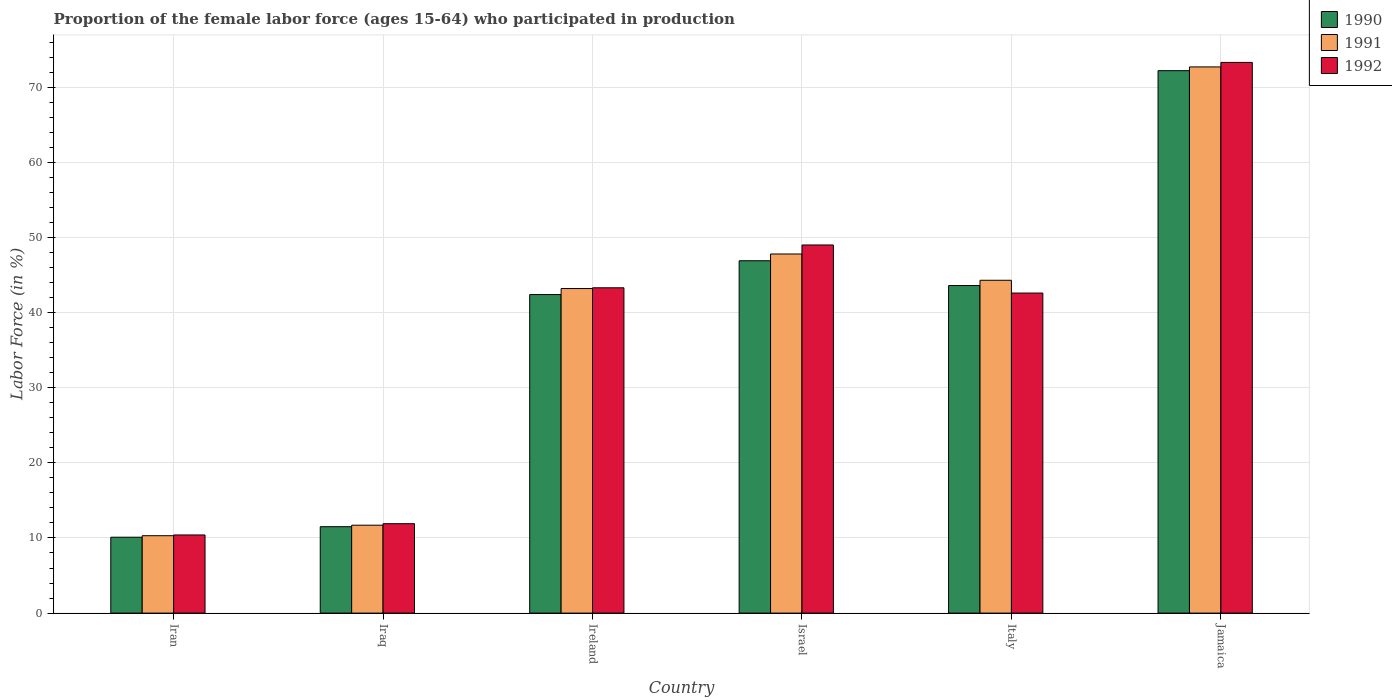Are the number of bars per tick equal to the number of legend labels?
Your answer should be very brief. Yes. How many bars are there on the 2nd tick from the left?
Offer a very short reply. 3. How many bars are there on the 3rd tick from the right?
Provide a succinct answer. 3. What is the label of the 2nd group of bars from the left?
Give a very brief answer. Iraq. In how many cases, is the number of bars for a given country not equal to the number of legend labels?
Provide a succinct answer. 0. What is the proportion of the female labor force who participated in production in 1991 in Israel?
Provide a succinct answer. 47.8. Across all countries, what is the maximum proportion of the female labor force who participated in production in 1992?
Your response must be concise. 73.3. Across all countries, what is the minimum proportion of the female labor force who participated in production in 1992?
Offer a terse response. 10.4. In which country was the proportion of the female labor force who participated in production in 1992 maximum?
Your answer should be compact. Jamaica. In which country was the proportion of the female labor force who participated in production in 1991 minimum?
Your answer should be very brief. Iran. What is the total proportion of the female labor force who participated in production in 1992 in the graph?
Keep it short and to the point. 230.5. What is the difference between the proportion of the female labor force who participated in production in 1992 in Iraq and that in Italy?
Provide a short and direct response. -30.7. What is the difference between the proportion of the female labor force who participated in production in 1992 in Iran and the proportion of the female labor force who participated in production in 1991 in Iraq?
Offer a very short reply. -1.3. What is the average proportion of the female labor force who participated in production in 1992 per country?
Give a very brief answer. 38.42. What is the difference between the proportion of the female labor force who participated in production of/in 1991 and proportion of the female labor force who participated in production of/in 1990 in Iraq?
Offer a very short reply. 0.2. In how many countries, is the proportion of the female labor force who participated in production in 1991 greater than 24 %?
Make the answer very short. 4. What is the ratio of the proportion of the female labor force who participated in production in 1991 in Ireland to that in Jamaica?
Provide a short and direct response. 0.59. Is the difference between the proportion of the female labor force who participated in production in 1991 in Israel and Italy greater than the difference between the proportion of the female labor force who participated in production in 1990 in Israel and Italy?
Give a very brief answer. Yes. What is the difference between the highest and the second highest proportion of the female labor force who participated in production in 1992?
Your answer should be very brief. 30. What is the difference between the highest and the lowest proportion of the female labor force who participated in production in 1990?
Make the answer very short. 62.1. In how many countries, is the proportion of the female labor force who participated in production in 1990 greater than the average proportion of the female labor force who participated in production in 1990 taken over all countries?
Ensure brevity in your answer.  4. Is the sum of the proportion of the female labor force who participated in production in 1992 in Ireland and Italy greater than the maximum proportion of the female labor force who participated in production in 1990 across all countries?
Offer a terse response. Yes. What does the 3rd bar from the left in Jamaica represents?
Offer a very short reply. 1992. Is it the case that in every country, the sum of the proportion of the female labor force who participated in production in 1992 and proportion of the female labor force who participated in production in 1991 is greater than the proportion of the female labor force who participated in production in 1990?
Provide a succinct answer. Yes. How many bars are there?
Your response must be concise. 18. How many countries are there in the graph?
Offer a very short reply. 6. What is the difference between two consecutive major ticks on the Y-axis?
Offer a very short reply. 10. Does the graph contain grids?
Provide a short and direct response. Yes. Where does the legend appear in the graph?
Provide a succinct answer. Top right. What is the title of the graph?
Offer a very short reply. Proportion of the female labor force (ages 15-64) who participated in production. Does "2008" appear as one of the legend labels in the graph?
Ensure brevity in your answer.  No. What is the label or title of the Y-axis?
Offer a terse response. Labor Force (in %). What is the Labor Force (in %) of 1990 in Iran?
Provide a succinct answer. 10.1. What is the Labor Force (in %) of 1991 in Iran?
Ensure brevity in your answer.  10.3. What is the Labor Force (in %) in 1992 in Iran?
Keep it short and to the point. 10.4. What is the Labor Force (in %) in 1991 in Iraq?
Your answer should be compact. 11.7. What is the Labor Force (in %) of 1992 in Iraq?
Your response must be concise. 11.9. What is the Labor Force (in %) in 1990 in Ireland?
Offer a very short reply. 42.4. What is the Labor Force (in %) in 1991 in Ireland?
Offer a terse response. 43.2. What is the Labor Force (in %) in 1992 in Ireland?
Give a very brief answer. 43.3. What is the Labor Force (in %) in 1990 in Israel?
Give a very brief answer. 46.9. What is the Labor Force (in %) of 1991 in Israel?
Provide a short and direct response. 47.8. What is the Labor Force (in %) of 1992 in Israel?
Your answer should be compact. 49. What is the Labor Force (in %) in 1990 in Italy?
Offer a very short reply. 43.6. What is the Labor Force (in %) in 1991 in Italy?
Provide a short and direct response. 44.3. What is the Labor Force (in %) in 1992 in Italy?
Your answer should be compact. 42.6. What is the Labor Force (in %) of 1990 in Jamaica?
Offer a very short reply. 72.2. What is the Labor Force (in %) in 1991 in Jamaica?
Ensure brevity in your answer.  72.7. What is the Labor Force (in %) in 1992 in Jamaica?
Your answer should be compact. 73.3. Across all countries, what is the maximum Labor Force (in %) of 1990?
Offer a terse response. 72.2. Across all countries, what is the maximum Labor Force (in %) in 1991?
Make the answer very short. 72.7. Across all countries, what is the maximum Labor Force (in %) of 1992?
Your answer should be very brief. 73.3. Across all countries, what is the minimum Labor Force (in %) in 1990?
Provide a short and direct response. 10.1. Across all countries, what is the minimum Labor Force (in %) in 1991?
Provide a short and direct response. 10.3. Across all countries, what is the minimum Labor Force (in %) in 1992?
Keep it short and to the point. 10.4. What is the total Labor Force (in %) in 1990 in the graph?
Provide a succinct answer. 226.7. What is the total Labor Force (in %) of 1991 in the graph?
Your answer should be compact. 230. What is the total Labor Force (in %) of 1992 in the graph?
Your answer should be very brief. 230.5. What is the difference between the Labor Force (in %) in 1990 in Iran and that in Iraq?
Offer a very short reply. -1.4. What is the difference between the Labor Force (in %) in 1991 in Iran and that in Iraq?
Provide a short and direct response. -1.4. What is the difference between the Labor Force (in %) in 1992 in Iran and that in Iraq?
Keep it short and to the point. -1.5. What is the difference between the Labor Force (in %) of 1990 in Iran and that in Ireland?
Make the answer very short. -32.3. What is the difference between the Labor Force (in %) of 1991 in Iran and that in Ireland?
Make the answer very short. -32.9. What is the difference between the Labor Force (in %) in 1992 in Iran and that in Ireland?
Ensure brevity in your answer.  -32.9. What is the difference between the Labor Force (in %) of 1990 in Iran and that in Israel?
Provide a succinct answer. -36.8. What is the difference between the Labor Force (in %) in 1991 in Iran and that in Israel?
Offer a very short reply. -37.5. What is the difference between the Labor Force (in %) of 1992 in Iran and that in Israel?
Offer a very short reply. -38.6. What is the difference between the Labor Force (in %) in 1990 in Iran and that in Italy?
Your answer should be compact. -33.5. What is the difference between the Labor Force (in %) in 1991 in Iran and that in Italy?
Your response must be concise. -34. What is the difference between the Labor Force (in %) in 1992 in Iran and that in Italy?
Your answer should be compact. -32.2. What is the difference between the Labor Force (in %) of 1990 in Iran and that in Jamaica?
Ensure brevity in your answer.  -62.1. What is the difference between the Labor Force (in %) in 1991 in Iran and that in Jamaica?
Ensure brevity in your answer.  -62.4. What is the difference between the Labor Force (in %) in 1992 in Iran and that in Jamaica?
Provide a succinct answer. -62.9. What is the difference between the Labor Force (in %) in 1990 in Iraq and that in Ireland?
Make the answer very short. -30.9. What is the difference between the Labor Force (in %) of 1991 in Iraq and that in Ireland?
Provide a short and direct response. -31.5. What is the difference between the Labor Force (in %) of 1992 in Iraq and that in Ireland?
Your answer should be compact. -31.4. What is the difference between the Labor Force (in %) in 1990 in Iraq and that in Israel?
Ensure brevity in your answer.  -35.4. What is the difference between the Labor Force (in %) of 1991 in Iraq and that in Israel?
Provide a short and direct response. -36.1. What is the difference between the Labor Force (in %) in 1992 in Iraq and that in Israel?
Provide a short and direct response. -37.1. What is the difference between the Labor Force (in %) of 1990 in Iraq and that in Italy?
Offer a terse response. -32.1. What is the difference between the Labor Force (in %) in 1991 in Iraq and that in Italy?
Ensure brevity in your answer.  -32.6. What is the difference between the Labor Force (in %) of 1992 in Iraq and that in Italy?
Your response must be concise. -30.7. What is the difference between the Labor Force (in %) in 1990 in Iraq and that in Jamaica?
Offer a terse response. -60.7. What is the difference between the Labor Force (in %) in 1991 in Iraq and that in Jamaica?
Keep it short and to the point. -61. What is the difference between the Labor Force (in %) in 1992 in Iraq and that in Jamaica?
Provide a succinct answer. -61.4. What is the difference between the Labor Force (in %) in 1991 in Ireland and that in Italy?
Offer a very short reply. -1.1. What is the difference between the Labor Force (in %) in 1990 in Ireland and that in Jamaica?
Give a very brief answer. -29.8. What is the difference between the Labor Force (in %) in 1991 in Ireland and that in Jamaica?
Keep it short and to the point. -29.5. What is the difference between the Labor Force (in %) of 1990 in Israel and that in Italy?
Your answer should be very brief. 3.3. What is the difference between the Labor Force (in %) of 1990 in Israel and that in Jamaica?
Provide a short and direct response. -25.3. What is the difference between the Labor Force (in %) in 1991 in Israel and that in Jamaica?
Make the answer very short. -24.9. What is the difference between the Labor Force (in %) in 1992 in Israel and that in Jamaica?
Ensure brevity in your answer.  -24.3. What is the difference between the Labor Force (in %) in 1990 in Italy and that in Jamaica?
Your answer should be compact. -28.6. What is the difference between the Labor Force (in %) of 1991 in Italy and that in Jamaica?
Keep it short and to the point. -28.4. What is the difference between the Labor Force (in %) of 1992 in Italy and that in Jamaica?
Offer a very short reply. -30.7. What is the difference between the Labor Force (in %) of 1991 in Iran and the Labor Force (in %) of 1992 in Iraq?
Your answer should be very brief. -1.6. What is the difference between the Labor Force (in %) of 1990 in Iran and the Labor Force (in %) of 1991 in Ireland?
Give a very brief answer. -33.1. What is the difference between the Labor Force (in %) in 1990 in Iran and the Labor Force (in %) in 1992 in Ireland?
Give a very brief answer. -33.2. What is the difference between the Labor Force (in %) of 1991 in Iran and the Labor Force (in %) of 1992 in Ireland?
Give a very brief answer. -33. What is the difference between the Labor Force (in %) of 1990 in Iran and the Labor Force (in %) of 1991 in Israel?
Ensure brevity in your answer.  -37.7. What is the difference between the Labor Force (in %) in 1990 in Iran and the Labor Force (in %) in 1992 in Israel?
Give a very brief answer. -38.9. What is the difference between the Labor Force (in %) of 1991 in Iran and the Labor Force (in %) of 1992 in Israel?
Ensure brevity in your answer.  -38.7. What is the difference between the Labor Force (in %) in 1990 in Iran and the Labor Force (in %) in 1991 in Italy?
Provide a short and direct response. -34.2. What is the difference between the Labor Force (in %) of 1990 in Iran and the Labor Force (in %) of 1992 in Italy?
Make the answer very short. -32.5. What is the difference between the Labor Force (in %) in 1991 in Iran and the Labor Force (in %) in 1992 in Italy?
Keep it short and to the point. -32.3. What is the difference between the Labor Force (in %) of 1990 in Iran and the Labor Force (in %) of 1991 in Jamaica?
Provide a short and direct response. -62.6. What is the difference between the Labor Force (in %) in 1990 in Iran and the Labor Force (in %) in 1992 in Jamaica?
Provide a succinct answer. -63.2. What is the difference between the Labor Force (in %) in 1991 in Iran and the Labor Force (in %) in 1992 in Jamaica?
Provide a short and direct response. -63. What is the difference between the Labor Force (in %) of 1990 in Iraq and the Labor Force (in %) of 1991 in Ireland?
Keep it short and to the point. -31.7. What is the difference between the Labor Force (in %) in 1990 in Iraq and the Labor Force (in %) in 1992 in Ireland?
Your answer should be very brief. -31.8. What is the difference between the Labor Force (in %) of 1991 in Iraq and the Labor Force (in %) of 1992 in Ireland?
Keep it short and to the point. -31.6. What is the difference between the Labor Force (in %) in 1990 in Iraq and the Labor Force (in %) in 1991 in Israel?
Offer a very short reply. -36.3. What is the difference between the Labor Force (in %) of 1990 in Iraq and the Labor Force (in %) of 1992 in Israel?
Ensure brevity in your answer.  -37.5. What is the difference between the Labor Force (in %) in 1991 in Iraq and the Labor Force (in %) in 1992 in Israel?
Offer a terse response. -37.3. What is the difference between the Labor Force (in %) in 1990 in Iraq and the Labor Force (in %) in 1991 in Italy?
Offer a very short reply. -32.8. What is the difference between the Labor Force (in %) of 1990 in Iraq and the Labor Force (in %) of 1992 in Italy?
Offer a terse response. -31.1. What is the difference between the Labor Force (in %) of 1991 in Iraq and the Labor Force (in %) of 1992 in Italy?
Give a very brief answer. -30.9. What is the difference between the Labor Force (in %) of 1990 in Iraq and the Labor Force (in %) of 1991 in Jamaica?
Offer a very short reply. -61.2. What is the difference between the Labor Force (in %) in 1990 in Iraq and the Labor Force (in %) in 1992 in Jamaica?
Ensure brevity in your answer.  -61.8. What is the difference between the Labor Force (in %) in 1991 in Iraq and the Labor Force (in %) in 1992 in Jamaica?
Your answer should be compact. -61.6. What is the difference between the Labor Force (in %) in 1991 in Ireland and the Labor Force (in %) in 1992 in Israel?
Keep it short and to the point. -5.8. What is the difference between the Labor Force (in %) of 1990 in Ireland and the Labor Force (in %) of 1991 in Italy?
Give a very brief answer. -1.9. What is the difference between the Labor Force (in %) in 1990 in Ireland and the Labor Force (in %) in 1991 in Jamaica?
Offer a very short reply. -30.3. What is the difference between the Labor Force (in %) of 1990 in Ireland and the Labor Force (in %) of 1992 in Jamaica?
Make the answer very short. -30.9. What is the difference between the Labor Force (in %) of 1991 in Ireland and the Labor Force (in %) of 1992 in Jamaica?
Your answer should be very brief. -30.1. What is the difference between the Labor Force (in %) in 1990 in Israel and the Labor Force (in %) in 1991 in Italy?
Ensure brevity in your answer.  2.6. What is the difference between the Labor Force (in %) of 1991 in Israel and the Labor Force (in %) of 1992 in Italy?
Make the answer very short. 5.2. What is the difference between the Labor Force (in %) of 1990 in Israel and the Labor Force (in %) of 1991 in Jamaica?
Make the answer very short. -25.8. What is the difference between the Labor Force (in %) of 1990 in Israel and the Labor Force (in %) of 1992 in Jamaica?
Provide a succinct answer. -26.4. What is the difference between the Labor Force (in %) of 1991 in Israel and the Labor Force (in %) of 1992 in Jamaica?
Provide a short and direct response. -25.5. What is the difference between the Labor Force (in %) of 1990 in Italy and the Labor Force (in %) of 1991 in Jamaica?
Give a very brief answer. -29.1. What is the difference between the Labor Force (in %) in 1990 in Italy and the Labor Force (in %) in 1992 in Jamaica?
Provide a short and direct response. -29.7. What is the average Labor Force (in %) in 1990 per country?
Offer a terse response. 37.78. What is the average Labor Force (in %) in 1991 per country?
Give a very brief answer. 38.33. What is the average Labor Force (in %) in 1992 per country?
Make the answer very short. 38.42. What is the difference between the Labor Force (in %) in 1990 and Labor Force (in %) in 1991 in Iran?
Your answer should be compact. -0.2. What is the difference between the Labor Force (in %) of 1991 and Labor Force (in %) of 1992 in Iraq?
Your answer should be very brief. -0.2. What is the difference between the Labor Force (in %) in 1991 and Labor Force (in %) in 1992 in Israel?
Your response must be concise. -1.2. What is the difference between the Labor Force (in %) of 1990 and Labor Force (in %) of 1991 in Italy?
Provide a short and direct response. -0.7. What is the difference between the Labor Force (in %) in 1990 and Labor Force (in %) in 1992 in Italy?
Ensure brevity in your answer.  1. What is the difference between the Labor Force (in %) in 1990 and Labor Force (in %) in 1991 in Jamaica?
Offer a very short reply. -0.5. What is the difference between the Labor Force (in %) of 1990 and Labor Force (in %) of 1992 in Jamaica?
Offer a very short reply. -1.1. What is the ratio of the Labor Force (in %) of 1990 in Iran to that in Iraq?
Your answer should be very brief. 0.88. What is the ratio of the Labor Force (in %) in 1991 in Iran to that in Iraq?
Keep it short and to the point. 0.88. What is the ratio of the Labor Force (in %) of 1992 in Iran to that in Iraq?
Your answer should be compact. 0.87. What is the ratio of the Labor Force (in %) of 1990 in Iran to that in Ireland?
Offer a very short reply. 0.24. What is the ratio of the Labor Force (in %) in 1991 in Iran to that in Ireland?
Your answer should be compact. 0.24. What is the ratio of the Labor Force (in %) in 1992 in Iran to that in Ireland?
Keep it short and to the point. 0.24. What is the ratio of the Labor Force (in %) of 1990 in Iran to that in Israel?
Ensure brevity in your answer.  0.22. What is the ratio of the Labor Force (in %) in 1991 in Iran to that in Israel?
Your response must be concise. 0.22. What is the ratio of the Labor Force (in %) in 1992 in Iran to that in Israel?
Ensure brevity in your answer.  0.21. What is the ratio of the Labor Force (in %) in 1990 in Iran to that in Italy?
Ensure brevity in your answer.  0.23. What is the ratio of the Labor Force (in %) in 1991 in Iran to that in Italy?
Provide a short and direct response. 0.23. What is the ratio of the Labor Force (in %) in 1992 in Iran to that in Italy?
Make the answer very short. 0.24. What is the ratio of the Labor Force (in %) in 1990 in Iran to that in Jamaica?
Ensure brevity in your answer.  0.14. What is the ratio of the Labor Force (in %) of 1991 in Iran to that in Jamaica?
Offer a very short reply. 0.14. What is the ratio of the Labor Force (in %) of 1992 in Iran to that in Jamaica?
Provide a short and direct response. 0.14. What is the ratio of the Labor Force (in %) in 1990 in Iraq to that in Ireland?
Make the answer very short. 0.27. What is the ratio of the Labor Force (in %) in 1991 in Iraq to that in Ireland?
Provide a succinct answer. 0.27. What is the ratio of the Labor Force (in %) in 1992 in Iraq to that in Ireland?
Provide a succinct answer. 0.27. What is the ratio of the Labor Force (in %) in 1990 in Iraq to that in Israel?
Provide a short and direct response. 0.25. What is the ratio of the Labor Force (in %) of 1991 in Iraq to that in Israel?
Your answer should be compact. 0.24. What is the ratio of the Labor Force (in %) in 1992 in Iraq to that in Israel?
Your response must be concise. 0.24. What is the ratio of the Labor Force (in %) of 1990 in Iraq to that in Italy?
Give a very brief answer. 0.26. What is the ratio of the Labor Force (in %) in 1991 in Iraq to that in Italy?
Offer a very short reply. 0.26. What is the ratio of the Labor Force (in %) in 1992 in Iraq to that in Italy?
Your response must be concise. 0.28. What is the ratio of the Labor Force (in %) in 1990 in Iraq to that in Jamaica?
Provide a short and direct response. 0.16. What is the ratio of the Labor Force (in %) of 1991 in Iraq to that in Jamaica?
Offer a terse response. 0.16. What is the ratio of the Labor Force (in %) in 1992 in Iraq to that in Jamaica?
Ensure brevity in your answer.  0.16. What is the ratio of the Labor Force (in %) in 1990 in Ireland to that in Israel?
Your answer should be compact. 0.9. What is the ratio of the Labor Force (in %) of 1991 in Ireland to that in Israel?
Make the answer very short. 0.9. What is the ratio of the Labor Force (in %) in 1992 in Ireland to that in Israel?
Offer a very short reply. 0.88. What is the ratio of the Labor Force (in %) of 1990 in Ireland to that in Italy?
Offer a very short reply. 0.97. What is the ratio of the Labor Force (in %) of 1991 in Ireland to that in Italy?
Your response must be concise. 0.98. What is the ratio of the Labor Force (in %) in 1992 in Ireland to that in Italy?
Make the answer very short. 1.02. What is the ratio of the Labor Force (in %) of 1990 in Ireland to that in Jamaica?
Keep it short and to the point. 0.59. What is the ratio of the Labor Force (in %) of 1991 in Ireland to that in Jamaica?
Your answer should be compact. 0.59. What is the ratio of the Labor Force (in %) in 1992 in Ireland to that in Jamaica?
Provide a short and direct response. 0.59. What is the ratio of the Labor Force (in %) in 1990 in Israel to that in Italy?
Provide a short and direct response. 1.08. What is the ratio of the Labor Force (in %) of 1991 in Israel to that in Italy?
Provide a succinct answer. 1.08. What is the ratio of the Labor Force (in %) of 1992 in Israel to that in Italy?
Your answer should be very brief. 1.15. What is the ratio of the Labor Force (in %) in 1990 in Israel to that in Jamaica?
Keep it short and to the point. 0.65. What is the ratio of the Labor Force (in %) of 1991 in Israel to that in Jamaica?
Keep it short and to the point. 0.66. What is the ratio of the Labor Force (in %) in 1992 in Israel to that in Jamaica?
Your answer should be very brief. 0.67. What is the ratio of the Labor Force (in %) of 1990 in Italy to that in Jamaica?
Offer a terse response. 0.6. What is the ratio of the Labor Force (in %) of 1991 in Italy to that in Jamaica?
Make the answer very short. 0.61. What is the ratio of the Labor Force (in %) in 1992 in Italy to that in Jamaica?
Offer a terse response. 0.58. What is the difference between the highest and the second highest Labor Force (in %) of 1990?
Ensure brevity in your answer.  25.3. What is the difference between the highest and the second highest Labor Force (in %) in 1991?
Make the answer very short. 24.9. What is the difference between the highest and the second highest Labor Force (in %) in 1992?
Offer a terse response. 24.3. What is the difference between the highest and the lowest Labor Force (in %) of 1990?
Make the answer very short. 62.1. What is the difference between the highest and the lowest Labor Force (in %) in 1991?
Ensure brevity in your answer.  62.4. What is the difference between the highest and the lowest Labor Force (in %) in 1992?
Offer a very short reply. 62.9. 